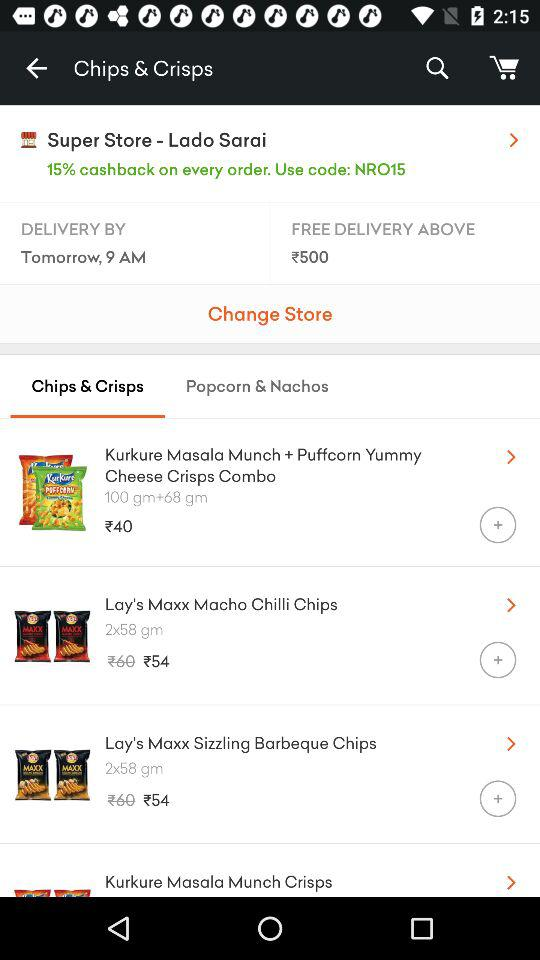What is the store name?
Answer the question using a single word or phrase. The store name is "Super Store-Lado Sarai." 